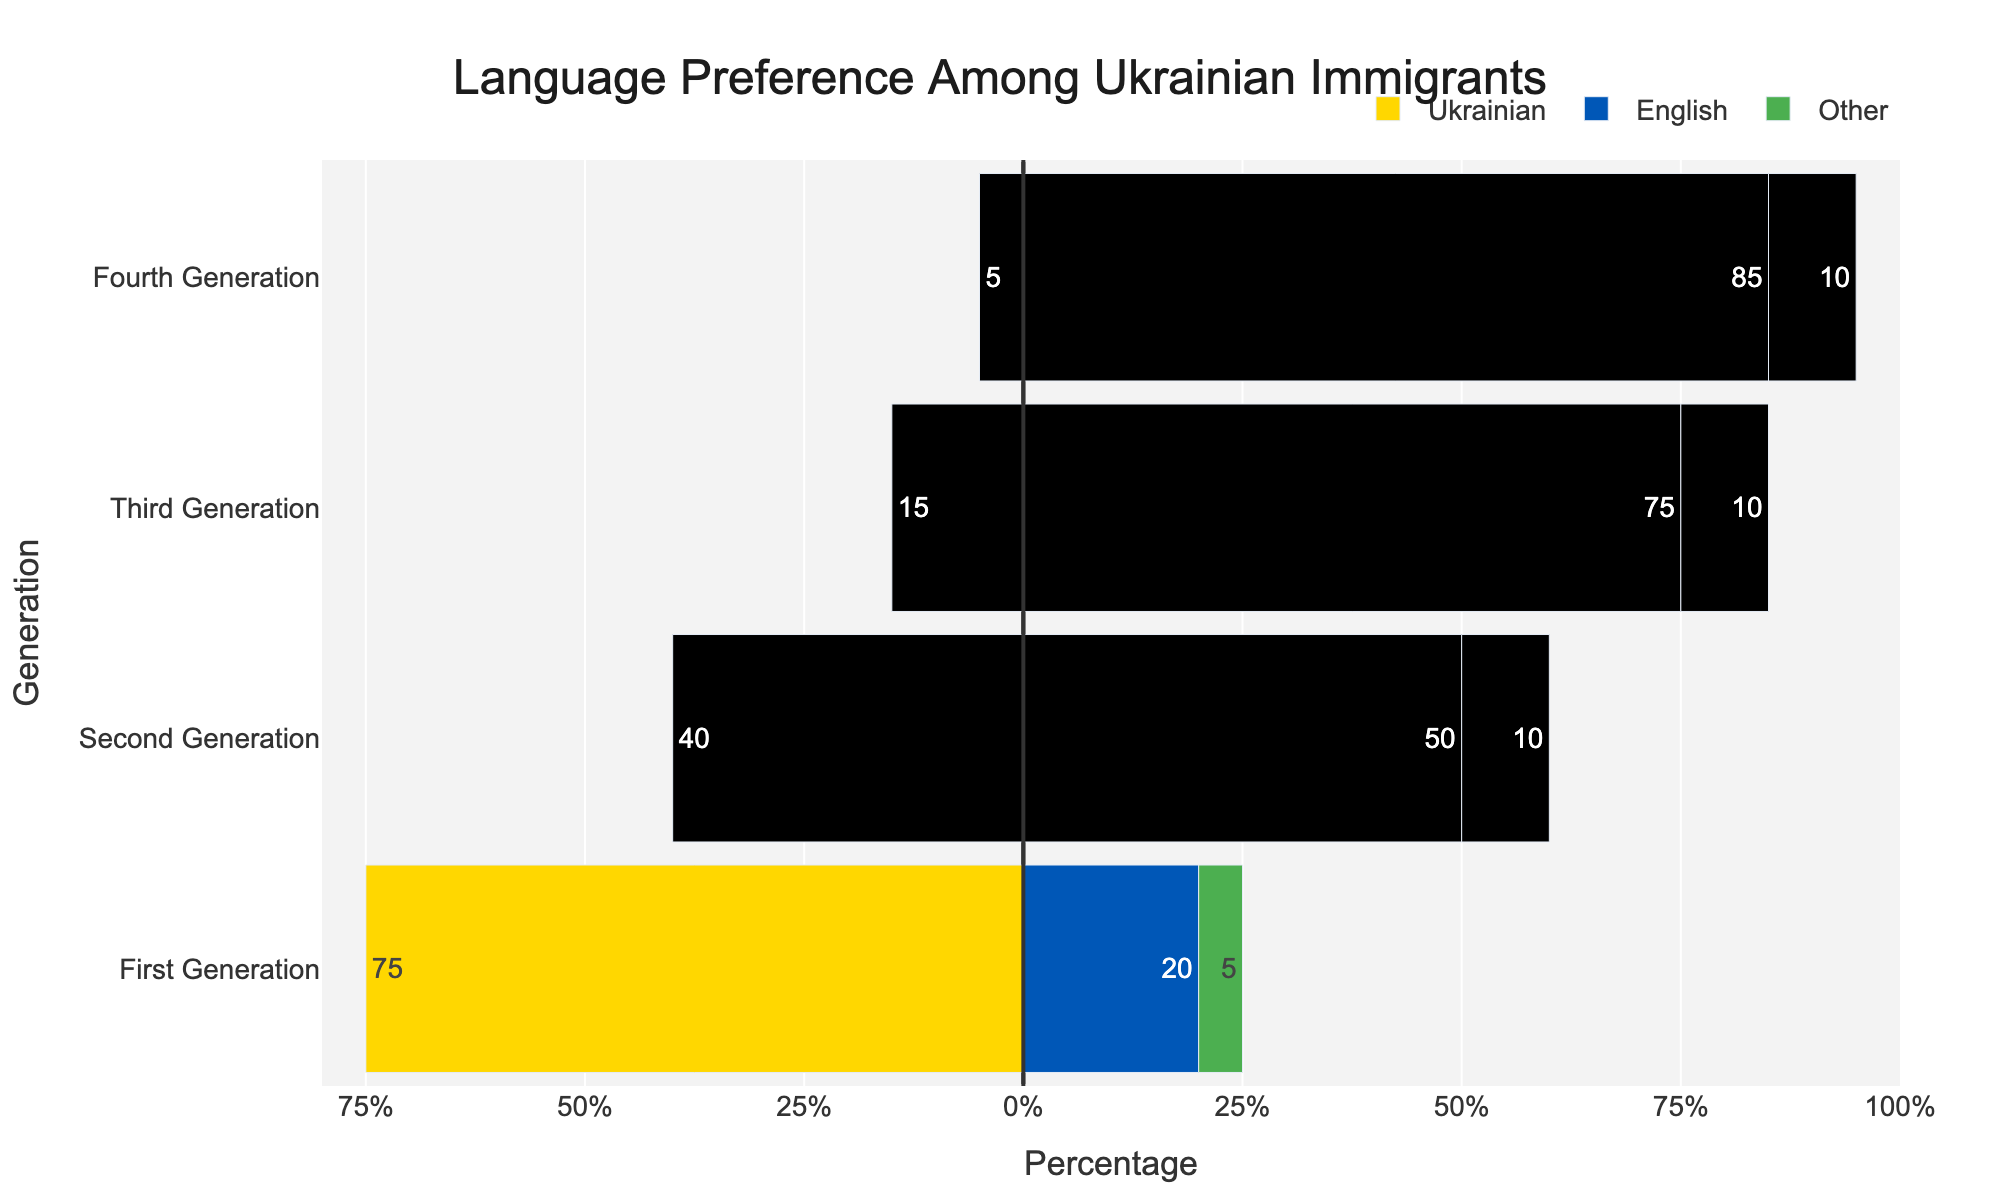What percentage of the Fourth Generation speaks English? The bar representing the Fourth Generation's preference for English extends to 85%, indicating 85% of the Fourth Generation speaks English.
Answer: 85% What is the difference in Ukrainian language preference between the First and Fourth Generation? The bar for the First Generation in Ukrainian is -75%, and for the Fourth Generation, it is -5%. The difference is 75% - 5% = 70%.
Answer: 70% Which generation has the highest preference for the Ukrainian language? By observing the negative bars (for Ukrainian), the largest extent is in the First Generation.
Answer: First Generation Compare the use of other languages between the Second and Third Generations. Which is higher? Both the Second and Third Generations have a 10% usage of other languages, so they are equal.
Answer: Equal What is the sum of the percentage preference for English across all generations? Adding the English preferences: 20% (First) + 50% (Second) + 75% (Third) + 85% (Fourth) = 230%.
Answer: 230% How much more popular is English compared to Ukrainian in the Third Generation? For the Third Generation, English preference is 75% and Ukrainian is 15%. The difference is 75% - 15% = 60%.
Answer: 60% Which language shows the least variation in preference across all generations? By observing the heights of the stacked bars for each language, 'Other' remains consistently at 5-10% across all generations, showing the least variation.
Answer: Other What is the average percentage of Ukrainian language preference across all generations? Adding the Ukrainian preferences: 75% (First) + 40% (Second) + 15% (Third) + 5% (Fourth) = 135%. There are 4 generations, so the average is 135% / 4 = 33.75%.
Answer: 33.75% Estimate the percentage gap between Ukrainian and English language preferences in the Second Generation. The Second Generation shows 40% preference for Ukrainian and 50% for English. The gap is 50% - 40% = 10%.
Answer: 10% 